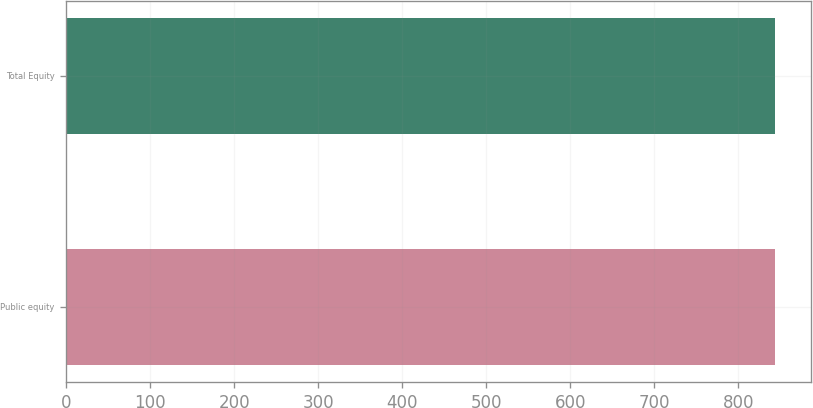Convert chart. <chart><loc_0><loc_0><loc_500><loc_500><bar_chart><fcel>Public equity<fcel>Total Equity<nl><fcel>843<fcel>844<nl></chart> 